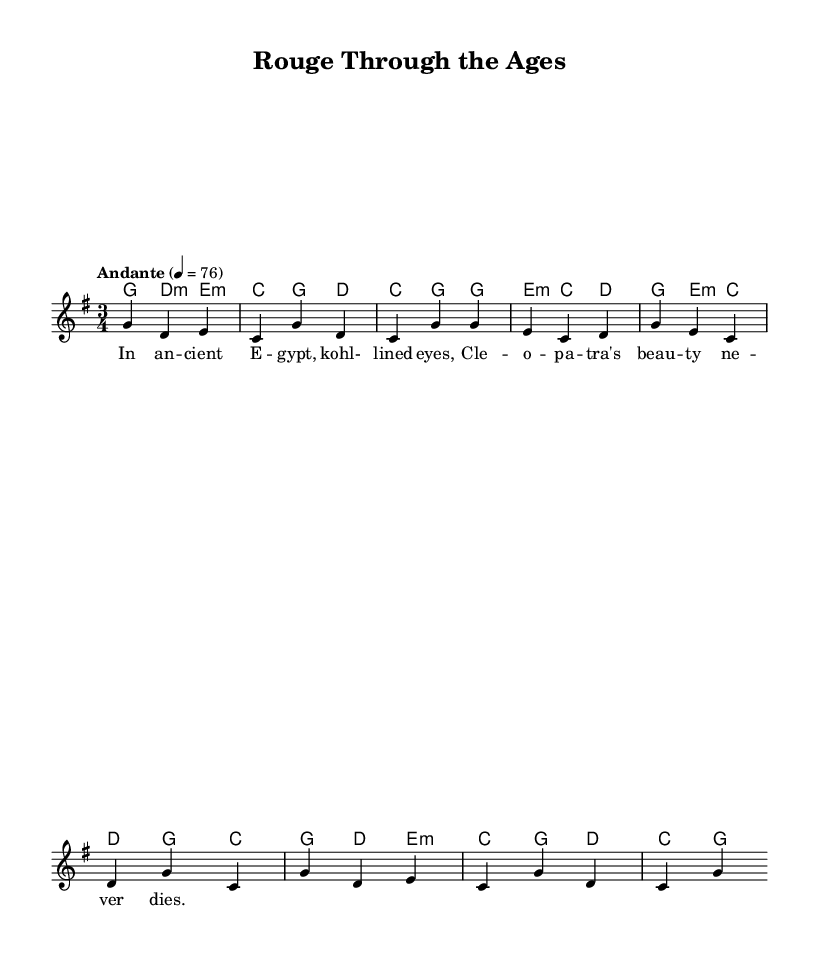What is the time signature of this music? The time signature is indicated at the beginning of the score and shows a 3 over 4, meaning there are three beats per measure and the quarter note gets one beat.
Answer: 3/4 What is the key signature of this music? The key signature is also shown at the beginning, which is one sharp, indicating that the piece is in G major.
Answer: G major What is the tempo marking? The tempo is specified in the score as "Andante," with a metronome marking of 76 beats per minute, indicating a moderate pace.
Answer: Andante How many measures are present in the melody section? By counting the measures in the melody line of the score, there are a total of seven measures visible in the provided excerpt.
Answer: Seven Which historical figure is referenced in the lyrics? The lyrics mention "Cleopatra," a significant historical figure known for her beauty and influence in ancient Egypt.
Answer: Cleopatra What instruments are indicated in the score? The score specifies the use of a single staff for the melody and a chord staff for harmonies without naming specific instruments, which implies it could be played on various instruments.
Answer: None specified What style does this piece represent regarding its lyrical content? The lyrical content reflects themes of beauty rituals and historical cosmetics, characteristic of folk ballads that tell stories from past cultures.
Answer: Folk ballad 